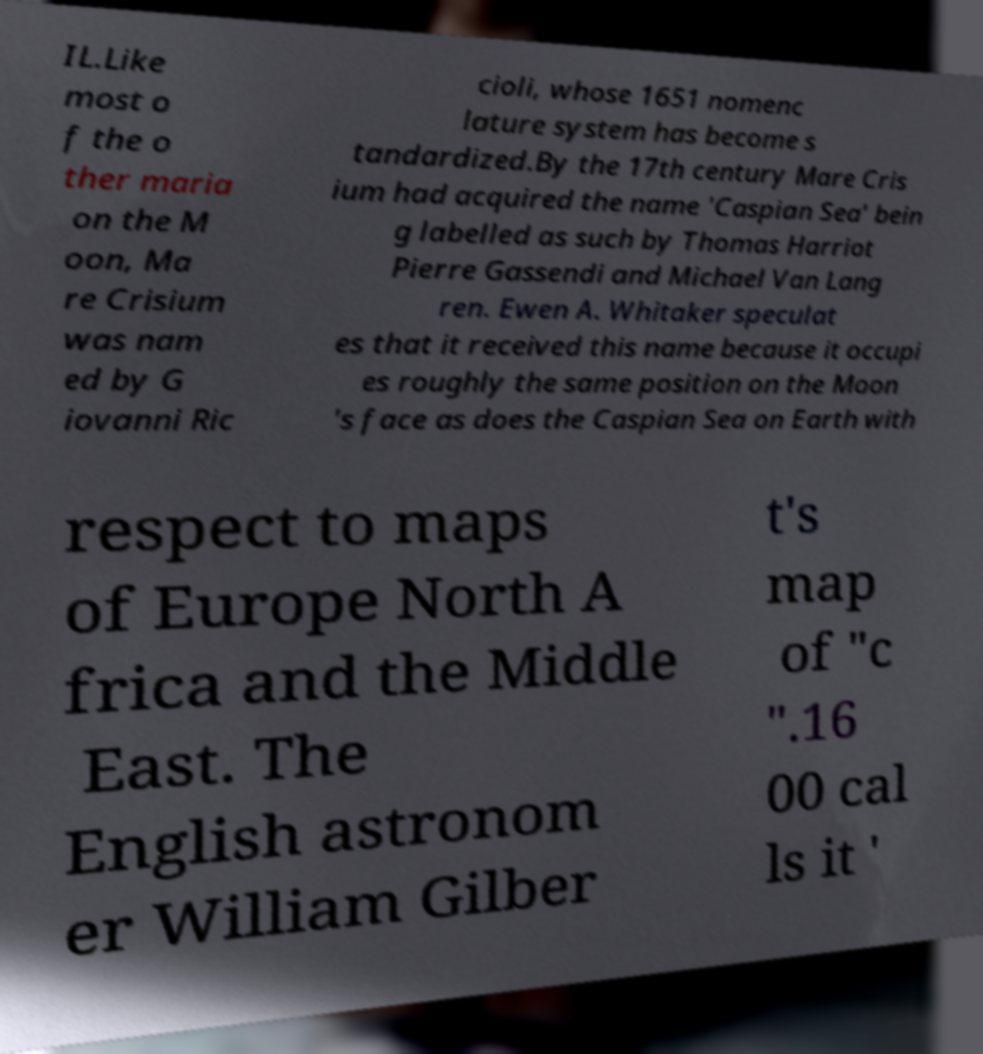Please identify and transcribe the text found in this image. IL.Like most o f the o ther maria on the M oon, Ma re Crisium was nam ed by G iovanni Ric cioli, whose 1651 nomenc lature system has become s tandardized.By the 17th century Mare Cris ium had acquired the name 'Caspian Sea' bein g labelled as such by Thomas Harriot Pierre Gassendi and Michael Van Lang ren. Ewen A. Whitaker speculat es that it received this name because it occupi es roughly the same position on the Moon 's face as does the Caspian Sea on Earth with respect to maps of Europe North A frica and the Middle East. The English astronom er William Gilber t's map of "c ".16 00 cal ls it ' 